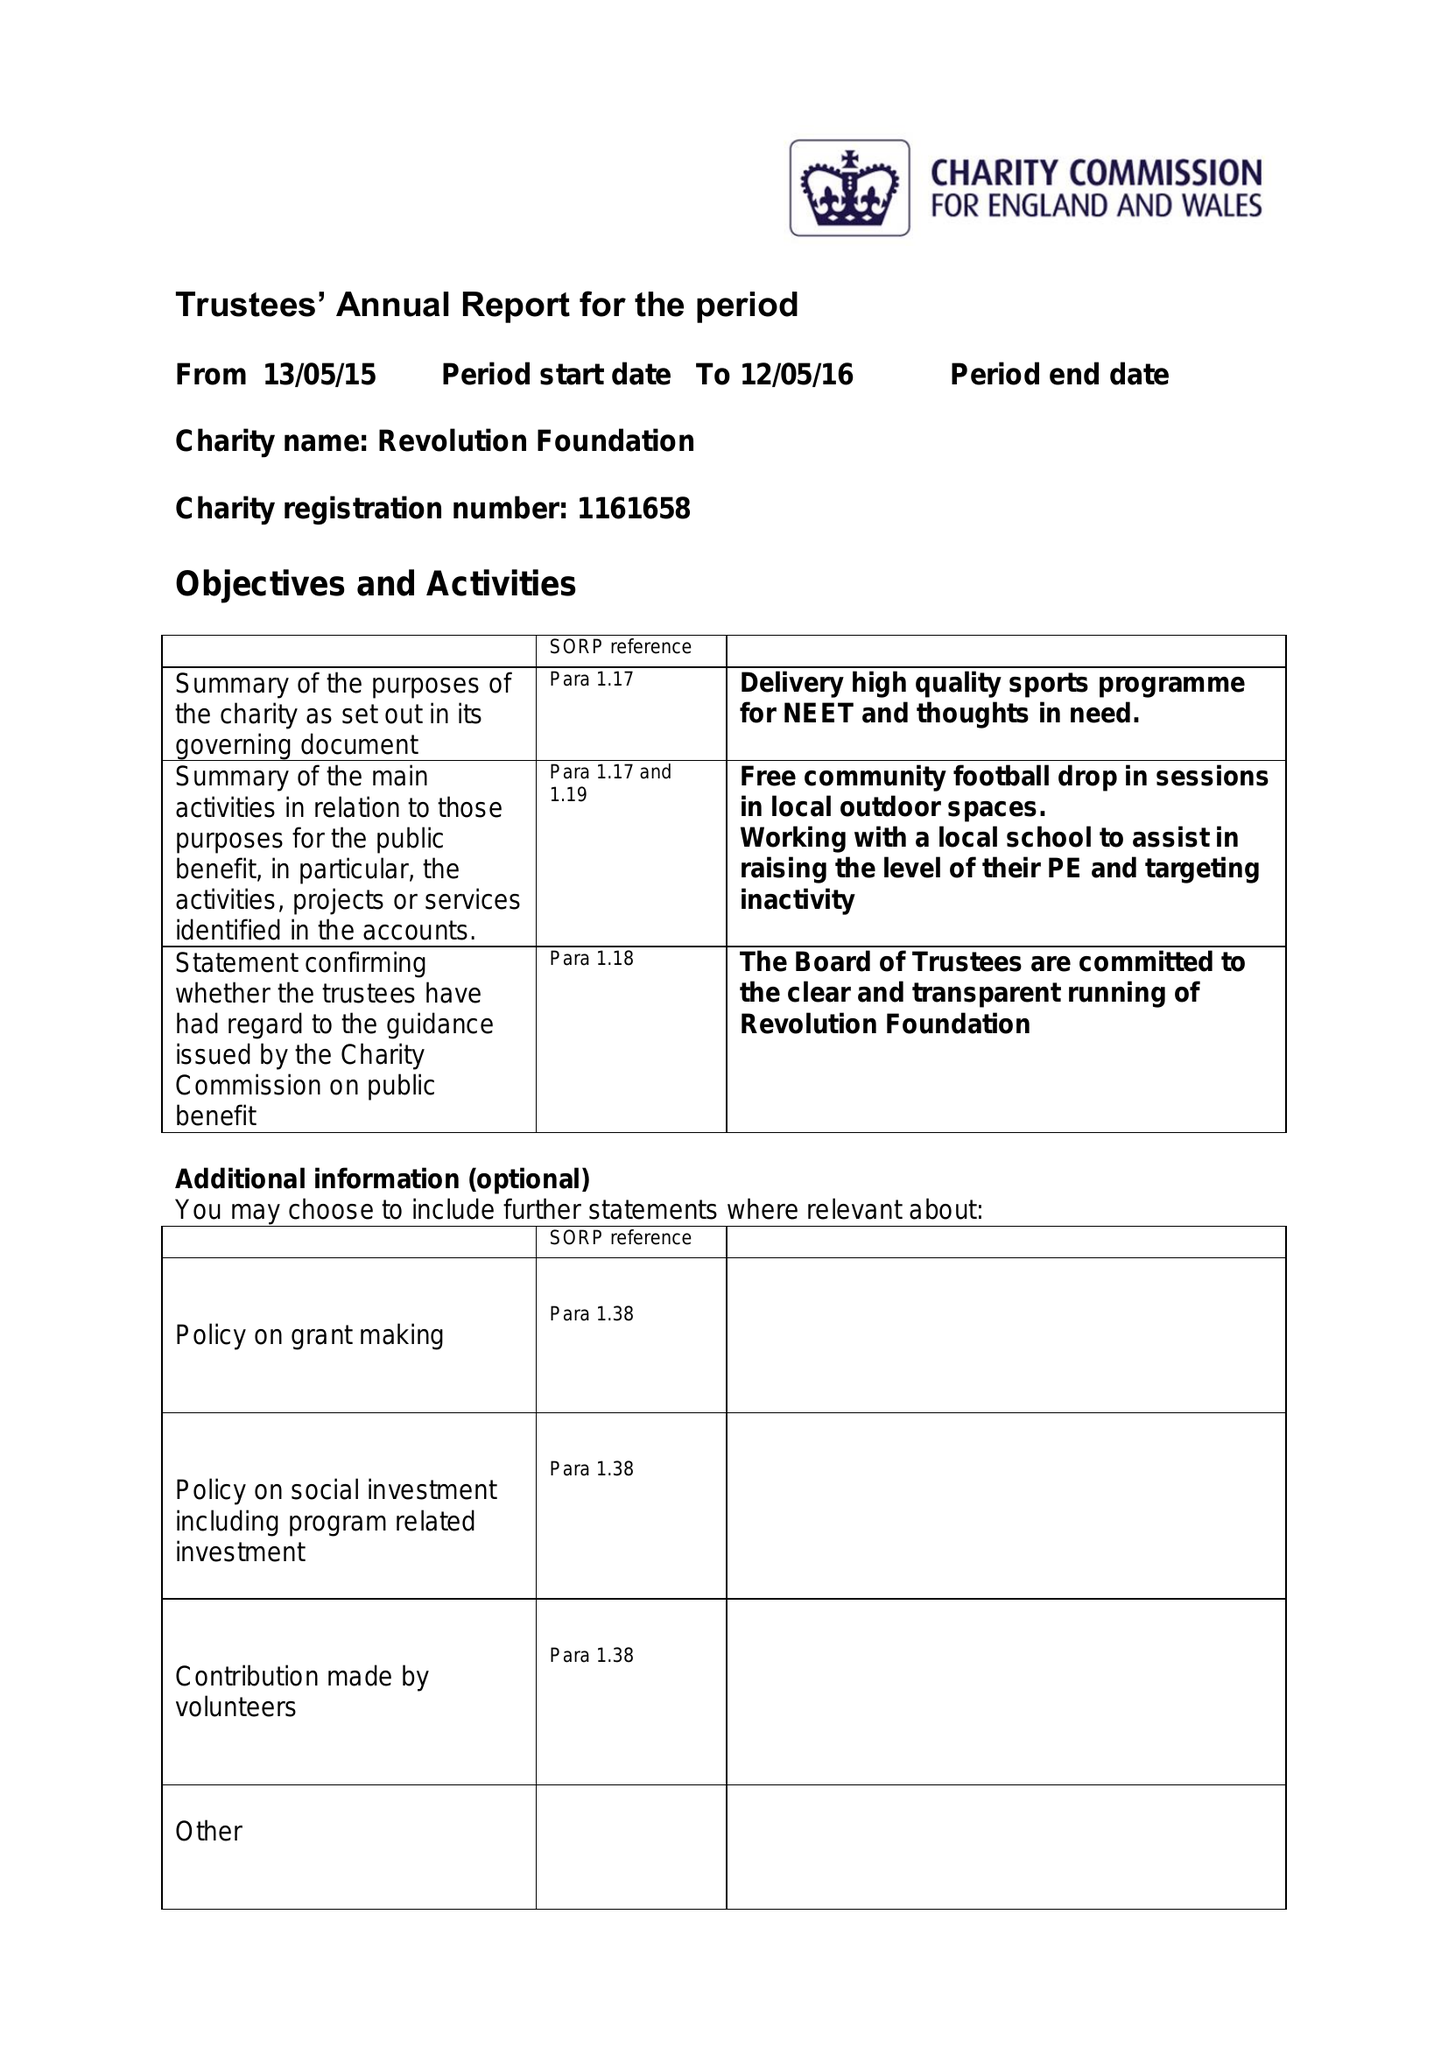What is the value for the income_annually_in_british_pounds?
Answer the question using a single word or phrase. 2160.00 